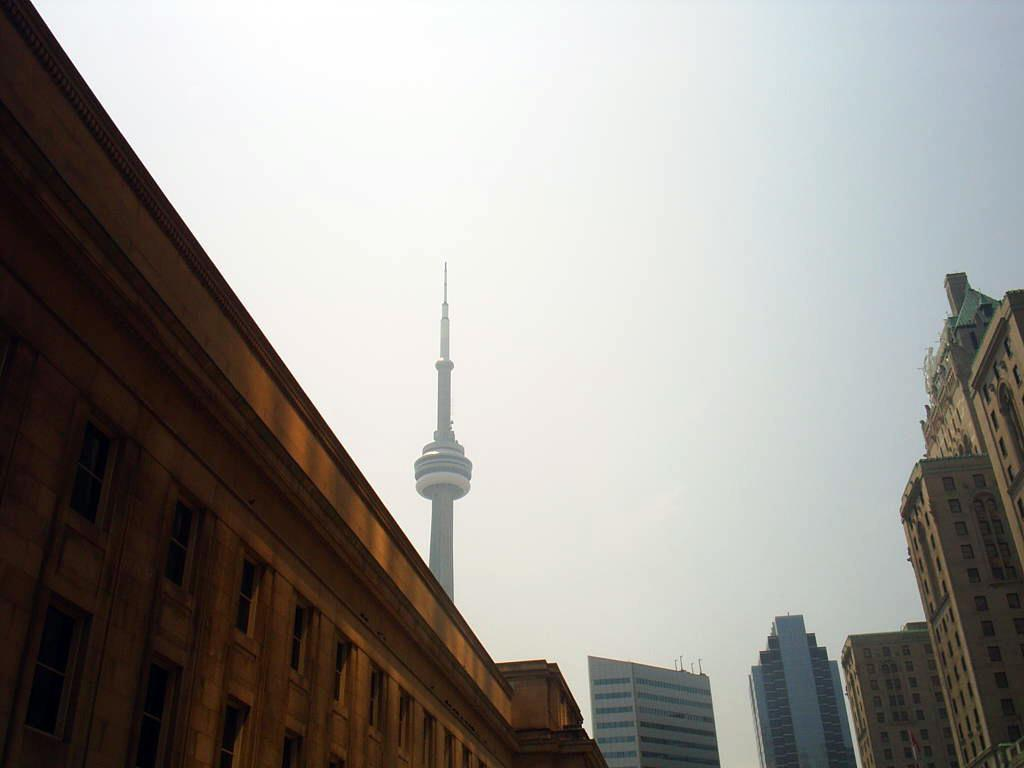What type of structures can be seen in the image? There are buildings and skyscrapers in the image. What is visible at the top of the image? The sky is visible at the top of the image. What specific type of building can be seen in the image? There is a tower in the image. What type of support does the spoon provide for the company in the image? There is no spoon or company present in the image. 